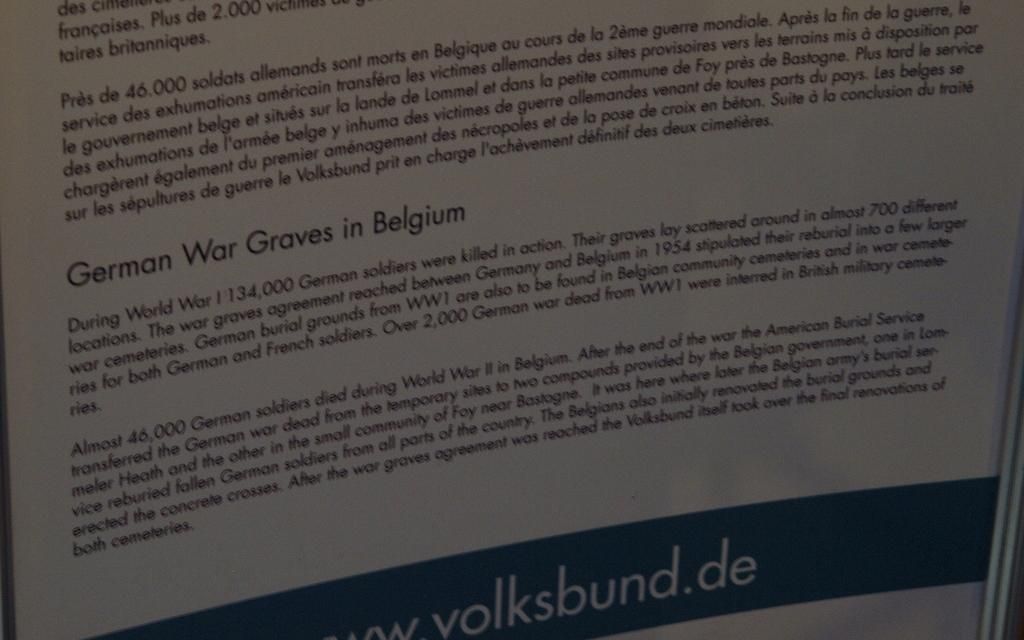Provide a one-sentence caption for the provided image. Paper that explains information about belgium that had the German war. 